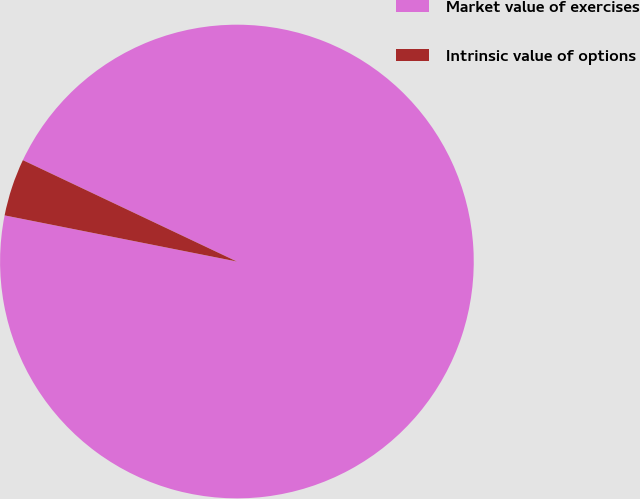Convert chart. <chart><loc_0><loc_0><loc_500><loc_500><pie_chart><fcel>Market value of exercises<fcel>Intrinsic value of options<nl><fcel>96.08%<fcel>3.92%<nl></chart> 